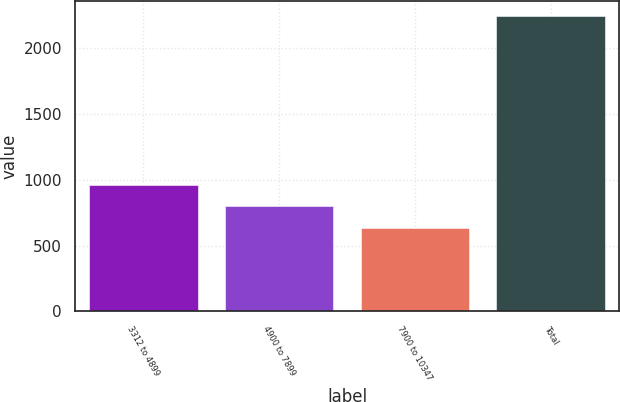<chart> <loc_0><loc_0><loc_500><loc_500><bar_chart><fcel>3312 to 4899<fcel>4900 to 7899<fcel>7900 to 10347<fcel>Total<nl><fcel>958<fcel>797.5<fcel>637<fcel>2242<nl></chart> 